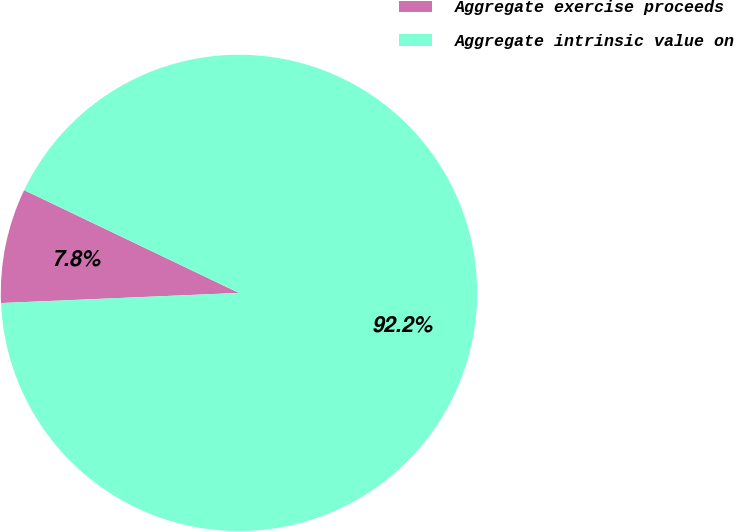Convert chart to OTSL. <chart><loc_0><loc_0><loc_500><loc_500><pie_chart><fcel>Aggregate exercise proceeds<fcel>Aggregate intrinsic value on<nl><fcel>7.78%<fcel>92.22%<nl></chart> 